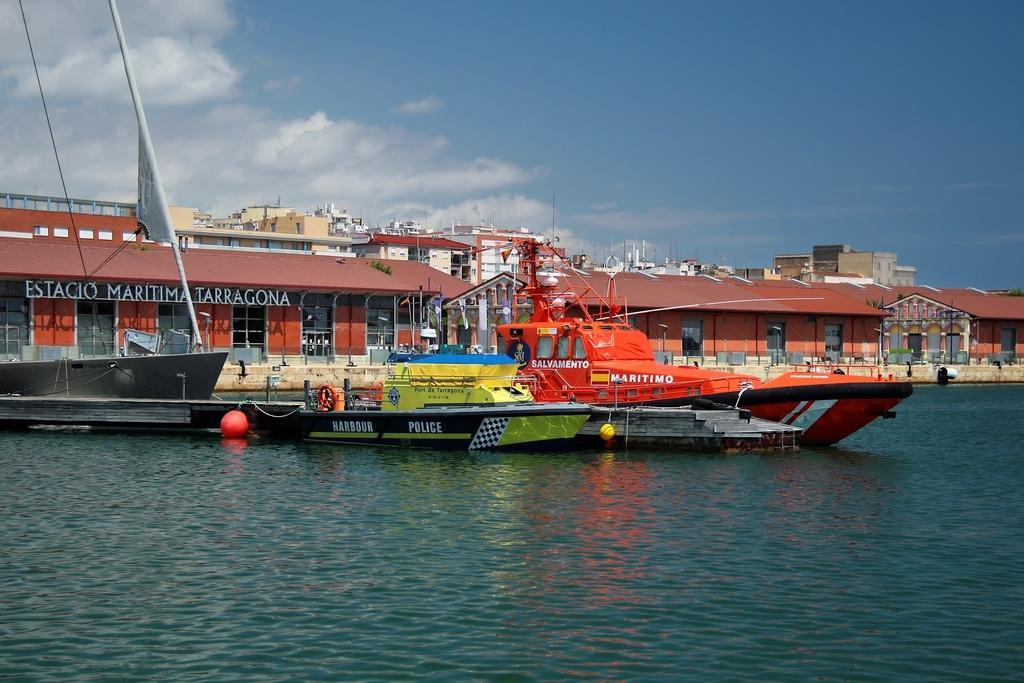Describe this image in one or two sentences. In this picture I can see there are few boats sailing on the water, among them there is a small green color boat with black paint and there is something written on it. There is a wooden bridge, there are few buildings at left side, with name plates, windows, doors. The sky is clear. 